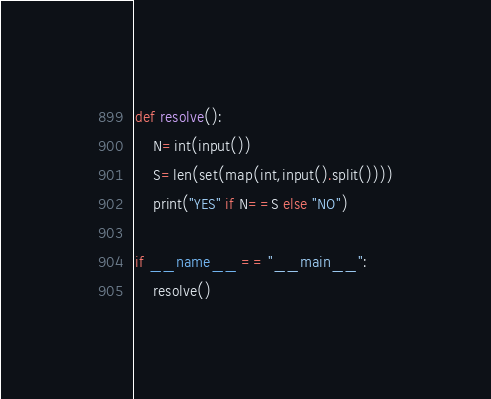<code> <loc_0><loc_0><loc_500><loc_500><_Python_>
def resolve():
    N=int(input())
    S=len(set(map(int,input().split())))
    print("YES" if N==S else "NO")

if __name__ == "__main__":
    resolve()</code> 